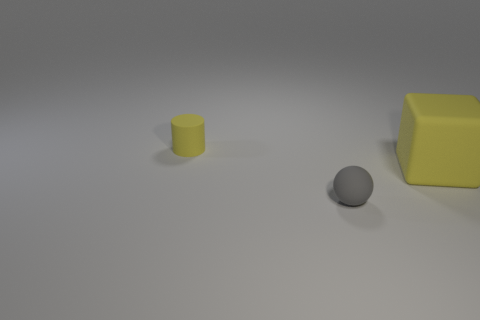Are there any other things that are the same size as the yellow block?
Make the answer very short. No. Are there any other things that have the same shape as the gray rubber thing?
Make the answer very short. No. Do the thing in front of the yellow matte cube and the thing that is behind the big block have the same color?
Offer a terse response. No. What number of yellow objects are large rubber cubes or cylinders?
Your answer should be compact. 2. Are there fewer big cubes to the right of the large matte object than matte balls on the right side of the ball?
Offer a terse response. No. Are there any other rubber spheres of the same size as the ball?
Make the answer very short. No. Do the rubber thing left of the matte ball and the large matte cube have the same size?
Provide a short and direct response. No. Are there more green objects than cylinders?
Provide a short and direct response. No. Is there another rubber thing of the same shape as the big thing?
Provide a succinct answer. No. The yellow object in front of the small cylinder has what shape?
Make the answer very short. Cube. 